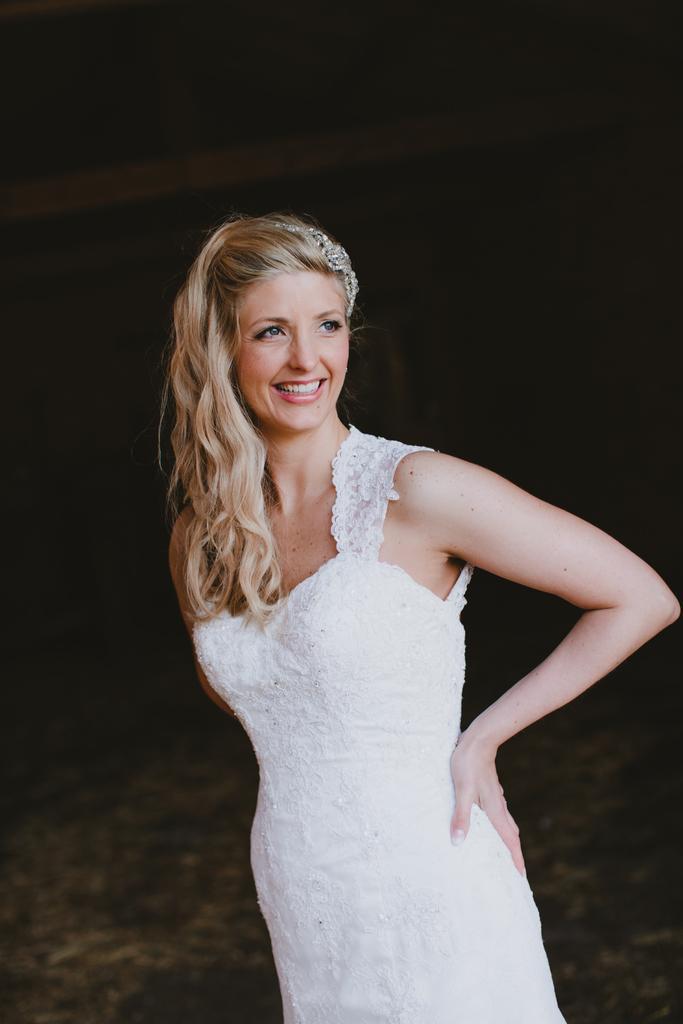In one or two sentences, can you explain what this image depicts? This is the woman standing and smiling. She wore a white dress. The background looks dark. 